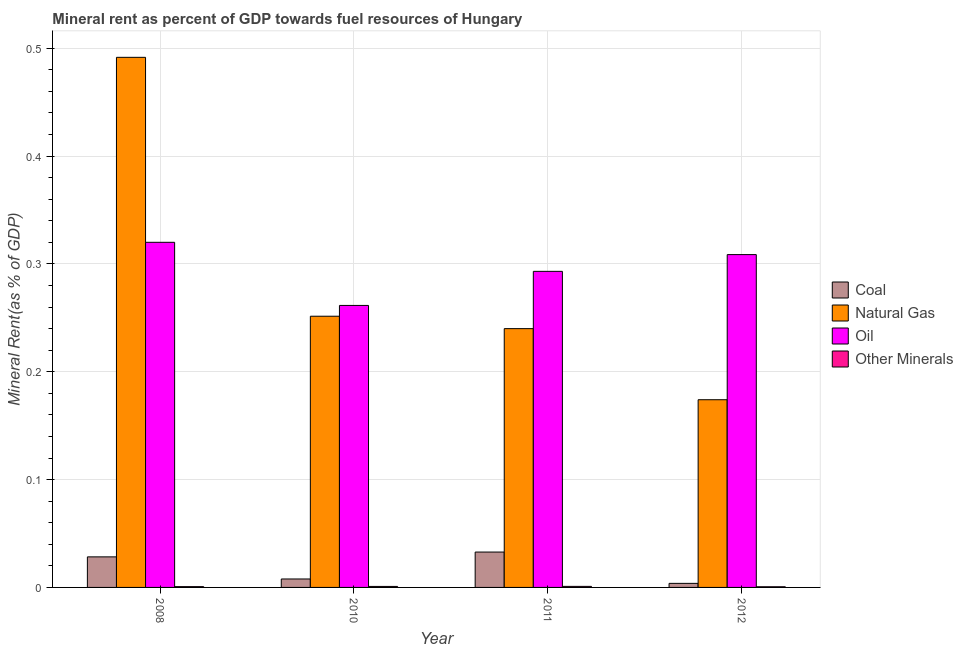How many different coloured bars are there?
Ensure brevity in your answer.  4. How many bars are there on the 1st tick from the left?
Your response must be concise. 4. How many bars are there on the 3rd tick from the right?
Your answer should be very brief. 4. What is the label of the 4th group of bars from the left?
Give a very brief answer. 2012. What is the oil rent in 2008?
Offer a very short reply. 0.32. Across all years, what is the maximum oil rent?
Make the answer very short. 0.32. Across all years, what is the minimum oil rent?
Offer a very short reply. 0.26. In which year was the  rent of other minerals maximum?
Keep it short and to the point. 2011. In which year was the  rent of other minerals minimum?
Your response must be concise. 2012. What is the total coal rent in the graph?
Offer a terse response. 0.07. What is the difference between the  rent of other minerals in 2010 and that in 2011?
Keep it short and to the point. -4.0162423750447e-5. What is the difference between the coal rent in 2008 and the oil rent in 2012?
Offer a terse response. 0.02. What is the average coal rent per year?
Provide a short and direct response. 0.02. What is the ratio of the oil rent in 2011 to that in 2012?
Ensure brevity in your answer.  0.95. Is the oil rent in 2010 less than that in 2011?
Provide a short and direct response. Yes. What is the difference between the highest and the second highest natural gas rent?
Offer a very short reply. 0.24. What is the difference between the highest and the lowest natural gas rent?
Offer a terse response. 0.32. Is it the case that in every year, the sum of the coal rent and  rent of other minerals is greater than the sum of oil rent and natural gas rent?
Provide a succinct answer. No. What does the 3rd bar from the left in 2010 represents?
Offer a very short reply. Oil. What does the 3rd bar from the right in 2012 represents?
Provide a short and direct response. Natural Gas. Is it the case that in every year, the sum of the coal rent and natural gas rent is greater than the oil rent?
Ensure brevity in your answer.  No. How many bars are there?
Your answer should be very brief. 16. Are all the bars in the graph horizontal?
Provide a succinct answer. No. How many years are there in the graph?
Give a very brief answer. 4. Does the graph contain any zero values?
Give a very brief answer. No. Does the graph contain grids?
Give a very brief answer. Yes. Where does the legend appear in the graph?
Provide a short and direct response. Center right. How many legend labels are there?
Offer a terse response. 4. How are the legend labels stacked?
Give a very brief answer. Vertical. What is the title of the graph?
Your response must be concise. Mineral rent as percent of GDP towards fuel resources of Hungary. What is the label or title of the Y-axis?
Your answer should be compact. Mineral Rent(as % of GDP). What is the Mineral Rent(as % of GDP) of Coal in 2008?
Give a very brief answer. 0.03. What is the Mineral Rent(as % of GDP) in Natural Gas in 2008?
Provide a succinct answer. 0.49. What is the Mineral Rent(as % of GDP) in Oil in 2008?
Provide a short and direct response. 0.32. What is the Mineral Rent(as % of GDP) in Other Minerals in 2008?
Give a very brief answer. 0. What is the Mineral Rent(as % of GDP) in Coal in 2010?
Provide a succinct answer. 0.01. What is the Mineral Rent(as % of GDP) in Natural Gas in 2010?
Your answer should be very brief. 0.25. What is the Mineral Rent(as % of GDP) of Oil in 2010?
Give a very brief answer. 0.26. What is the Mineral Rent(as % of GDP) of Other Minerals in 2010?
Ensure brevity in your answer.  0. What is the Mineral Rent(as % of GDP) in Coal in 2011?
Ensure brevity in your answer.  0.03. What is the Mineral Rent(as % of GDP) of Natural Gas in 2011?
Offer a very short reply. 0.24. What is the Mineral Rent(as % of GDP) in Oil in 2011?
Offer a very short reply. 0.29. What is the Mineral Rent(as % of GDP) of Other Minerals in 2011?
Offer a very short reply. 0. What is the Mineral Rent(as % of GDP) of Coal in 2012?
Offer a very short reply. 0. What is the Mineral Rent(as % of GDP) in Natural Gas in 2012?
Provide a short and direct response. 0.17. What is the Mineral Rent(as % of GDP) in Oil in 2012?
Keep it short and to the point. 0.31. What is the Mineral Rent(as % of GDP) of Other Minerals in 2012?
Offer a terse response. 0. Across all years, what is the maximum Mineral Rent(as % of GDP) in Coal?
Offer a terse response. 0.03. Across all years, what is the maximum Mineral Rent(as % of GDP) in Natural Gas?
Your answer should be very brief. 0.49. Across all years, what is the maximum Mineral Rent(as % of GDP) of Oil?
Your answer should be compact. 0.32. Across all years, what is the maximum Mineral Rent(as % of GDP) of Other Minerals?
Offer a terse response. 0. Across all years, what is the minimum Mineral Rent(as % of GDP) of Coal?
Make the answer very short. 0. Across all years, what is the minimum Mineral Rent(as % of GDP) in Natural Gas?
Your response must be concise. 0.17. Across all years, what is the minimum Mineral Rent(as % of GDP) in Oil?
Keep it short and to the point. 0.26. Across all years, what is the minimum Mineral Rent(as % of GDP) of Other Minerals?
Offer a very short reply. 0. What is the total Mineral Rent(as % of GDP) of Coal in the graph?
Keep it short and to the point. 0.07. What is the total Mineral Rent(as % of GDP) in Natural Gas in the graph?
Your answer should be very brief. 1.16. What is the total Mineral Rent(as % of GDP) in Oil in the graph?
Ensure brevity in your answer.  1.18. What is the total Mineral Rent(as % of GDP) in Other Minerals in the graph?
Provide a short and direct response. 0. What is the difference between the Mineral Rent(as % of GDP) of Coal in 2008 and that in 2010?
Your response must be concise. 0.02. What is the difference between the Mineral Rent(as % of GDP) of Natural Gas in 2008 and that in 2010?
Your answer should be compact. 0.24. What is the difference between the Mineral Rent(as % of GDP) in Oil in 2008 and that in 2010?
Make the answer very short. 0.06. What is the difference between the Mineral Rent(as % of GDP) of Other Minerals in 2008 and that in 2010?
Provide a succinct answer. -0. What is the difference between the Mineral Rent(as % of GDP) in Coal in 2008 and that in 2011?
Your answer should be very brief. -0. What is the difference between the Mineral Rent(as % of GDP) in Natural Gas in 2008 and that in 2011?
Ensure brevity in your answer.  0.25. What is the difference between the Mineral Rent(as % of GDP) of Oil in 2008 and that in 2011?
Your answer should be very brief. 0.03. What is the difference between the Mineral Rent(as % of GDP) of Other Minerals in 2008 and that in 2011?
Make the answer very short. -0. What is the difference between the Mineral Rent(as % of GDP) of Coal in 2008 and that in 2012?
Offer a terse response. 0.02. What is the difference between the Mineral Rent(as % of GDP) in Natural Gas in 2008 and that in 2012?
Offer a terse response. 0.32. What is the difference between the Mineral Rent(as % of GDP) in Oil in 2008 and that in 2012?
Your answer should be compact. 0.01. What is the difference between the Mineral Rent(as % of GDP) in Coal in 2010 and that in 2011?
Ensure brevity in your answer.  -0.03. What is the difference between the Mineral Rent(as % of GDP) of Natural Gas in 2010 and that in 2011?
Offer a terse response. 0.01. What is the difference between the Mineral Rent(as % of GDP) of Oil in 2010 and that in 2011?
Your answer should be compact. -0.03. What is the difference between the Mineral Rent(as % of GDP) in Coal in 2010 and that in 2012?
Provide a succinct answer. 0. What is the difference between the Mineral Rent(as % of GDP) in Natural Gas in 2010 and that in 2012?
Provide a succinct answer. 0.08. What is the difference between the Mineral Rent(as % of GDP) in Oil in 2010 and that in 2012?
Offer a terse response. -0.05. What is the difference between the Mineral Rent(as % of GDP) of Other Minerals in 2010 and that in 2012?
Your answer should be very brief. 0. What is the difference between the Mineral Rent(as % of GDP) in Coal in 2011 and that in 2012?
Your response must be concise. 0.03. What is the difference between the Mineral Rent(as % of GDP) in Natural Gas in 2011 and that in 2012?
Keep it short and to the point. 0.07. What is the difference between the Mineral Rent(as % of GDP) of Oil in 2011 and that in 2012?
Your response must be concise. -0.02. What is the difference between the Mineral Rent(as % of GDP) of Coal in 2008 and the Mineral Rent(as % of GDP) of Natural Gas in 2010?
Give a very brief answer. -0.22. What is the difference between the Mineral Rent(as % of GDP) of Coal in 2008 and the Mineral Rent(as % of GDP) of Oil in 2010?
Give a very brief answer. -0.23. What is the difference between the Mineral Rent(as % of GDP) in Coal in 2008 and the Mineral Rent(as % of GDP) in Other Minerals in 2010?
Provide a succinct answer. 0.03. What is the difference between the Mineral Rent(as % of GDP) of Natural Gas in 2008 and the Mineral Rent(as % of GDP) of Oil in 2010?
Provide a short and direct response. 0.23. What is the difference between the Mineral Rent(as % of GDP) of Natural Gas in 2008 and the Mineral Rent(as % of GDP) of Other Minerals in 2010?
Your answer should be compact. 0.49. What is the difference between the Mineral Rent(as % of GDP) of Oil in 2008 and the Mineral Rent(as % of GDP) of Other Minerals in 2010?
Ensure brevity in your answer.  0.32. What is the difference between the Mineral Rent(as % of GDP) of Coal in 2008 and the Mineral Rent(as % of GDP) of Natural Gas in 2011?
Your answer should be very brief. -0.21. What is the difference between the Mineral Rent(as % of GDP) of Coal in 2008 and the Mineral Rent(as % of GDP) of Oil in 2011?
Your answer should be compact. -0.26. What is the difference between the Mineral Rent(as % of GDP) of Coal in 2008 and the Mineral Rent(as % of GDP) of Other Minerals in 2011?
Your response must be concise. 0.03. What is the difference between the Mineral Rent(as % of GDP) in Natural Gas in 2008 and the Mineral Rent(as % of GDP) in Oil in 2011?
Ensure brevity in your answer.  0.2. What is the difference between the Mineral Rent(as % of GDP) of Natural Gas in 2008 and the Mineral Rent(as % of GDP) of Other Minerals in 2011?
Keep it short and to the point. 0.49. What is the difference between the Mineral Rent(as % of GDP) of Oil in 2008 and the Mineral Rent(as % of GDP) of Other Minerals in 2011?
Your answer should be very brief. 0.32. What is the difference between the Mineral Rent(as % of GDP) of Coal in 2008 and the Mineral Rent(as % of GDP) of Natural Gas in 2012?
Offer a terse response. -0.15. What is the difference between the Mineral Rent(as % of GDP) of Coal in 2008 and the Mineral Rent(as % of GDP) of Oil in 2012?
Your response must be concise. -0.28. What is the difference between the Mineral Rent(as % of GDP) in Coal in 2008 and the Mineral Rent(as % of GDP) in Other Minerals in 2012?
Your answer should be compact. 0.03. What is the difference between the Mineral Rent(as % of GDP) in Natural Gas in 2008 and the Mineral Rent(as % of GDP) in Oil in 2012?
Your answer should be compact. 0.18. What is the difference between the Mineral Rent(as % of GDP) of Natural Gas in 2008 and the Mineral Rent(as % of GDP) of Other Minerals in 2012?
Offer a very short reply. 0.49. What is the difference between the Mineral Rent(as % of GDP) of Oil in 2008 and the Mineral Rent(as % of GDP) of Other Minerals in 2012?
Offer a very short reply. 0.32. What is the difference between the Mineral Rent(as % of GDP) of Coal in 2010 and the Mineral Rent(as % of GDP) of Natural Gas in 2011?
Your answer should be very brief. -0.23. What is the difference between the Mineral Rent(as % of GDP) in Coal in 2010 and the Mineral Rent(as % of GDP) in Oil in 2011?
Your answer should be very brief. -0.29. What is the difference between the Mineral Rent(as % of GDP) of Coal in 2010 and the Mineral Rent(as % of GDP) of Other Minerals in 2011?
Your response must be concise. 0.01. What is the difference between the Mineral Rent(as % of GDP) in Natural Gas in 2010 and the Mineral Rent(as % of GDP) in Oil in 2011?
Keep it short and to the point. -0.04. What is the difference between the Mineral Rent(as % of GDP) in Natural Gas in 2010 and the Mineral Rent(as % of GDP) in Other Minerals in 2011?
Give a very brief answer. 0.25. What is the difference between the Mineral Rent(as % of GDP) of Oil in 2010 and the Mineral Rent(as % of GDP) of Other Minerals in 2011?
Offer a terse response. 0.26. What is the difference between the Mineral Rent(as % of GDP) of Coal in 2010 and the Mineral Rent(as % of GDP) of Natural Gas in 2012?
Your answer should be very brief. -0.17. What is the difference between the Mineral Rent(as % of GDP) in Coal in 2010 and the Mineral Rent(as % of GDP) in Oil in 2012?
Ensure brevity in your answer.  -0.3. What is the difference between the Mineral Rent(as % of GDP) of Coal in 2010 and the Mineral Rent(as % of GDP) of Other Minerals in 2012?
Provide a short and direct response. 0.01. What is the difference between the Mineral Rent(as % of GDP) of Natural Gas in 2010 and the Mineral Rent(as % of GDP) of Oil in 2012?
Provide a short and direct response. -0.06. What is the difference between the Mineral Rent(as % of GDP) in Natural Gas in 2010 and the Mineral Rent(as % of GDP) in Other Minerals in 2012?
Your response must be concise. 0.25. What is the difference between the Mineral Rent(as % of GDP) in Oil in 2010 and the Mineral Rent(as % of GDP) in Other Minerals in 2012?
Give a very brief answer. 0.26. What is the difference between the Mineral Rent(as % of GDP) of Coal in 2011 and the Mineral Rent(as % of GDP) of Natural Gas in 2012?
Offer a terse response. -0.14. What is the difference between the Mineral Rent(as % of GDP) of Coal in 2011 and the Mineral Rent(as % of GDP) of Oil in 2012?
Provide a short and direct response. -0.28. What is the difference between the Mineral Rent(as % of GDP) of Coal in 2011 and the Mineral Rent(as % of GDP) of Other Minerals in 2012?
Your answer should be very brief. 0.03. What is the difference between the Mineral Rent(as % of GDP) in Natural Gas in 2011 and the Mineral Rent(as % of GDP) in Oil in 2012?
Make the answer very short. -0.07. What is the difference between the Mineral Rent(as % of GDP) of Natural Gas in 2011 and the Mineral Rent(as % of GDP) of Other Minerals in 2012?
Make the answer very short. 0.24. What is the difference between the Mineral Rent(as % of GDP) in Oil in 2011 and the Mineral Rent(as % of GDP) in Other Minerals in 2012?
Keep it short and to the point. 0.29. What is the average Mineral Rent(as % of GDP) in Coal per year?
Give a very brief answer. 0.02. What is the average Mineral Rent(as % of GDP) of Natural Gas per year?
Ensure brevity in your answer.  0.29. What is the average Mineral Rent(as % of GDP) in Oil per year?
Ensure brevity in your answer.  0.3. What is the average Mineral Rent(as % of GDP) of Other Minerals per year?
Make the answer very short. 0. In the year 2008, what is the difference between the Mineral Rent(as % of GDP) of Coal and Mineral Rent(as % of GDP) of Natural Gas?
Offer a very short reply. -0.46. In the year 2008, what is the difference between the Mineral Rent(as % of GDP) of Coal and Mineral Rent(as % of GDP) of Oil?
Make the answer very short. -0.29. In the year 2008, what is the difference between the Mineral Rent(as % of GDP) of Coal and Mineral Rent(as % of GDP) of Other Minerals?
Provide a short and direct response. 0.03. In the year 2008, what is the difference between the Mineral Rent(as % of GDP) in Natural Gas and Mineral Rent(as % of GDP) in Oil?
Make the answer very short. 0.17. In the year 2008, what is the difference between the Mineral Rent(as % of GDP) in Natural Gas and Mineral Rent(as % of GDP) in Other Minerals?
Make the answer very short. 0.49. In the year 2008, what is the difference between the Mineral Rent(as % of GDP) of Oil and Mineral Rent(as % of GDP) of Other Minerals?
Your response must be concise. 0.32. In the year 2010, what is the difference between the Mineral Rent(as % of GDP) in Coal and Mineral Rent(as % of GDP) in Natural Gas?
Your response must be concise. -0.24. In the year 2010, what is the difference between the Mineral Rent(as % of GDP) of Coal and Mineral Rent(as % of GDP) of Oil?
Make the answer very short. -0.25. In the year 2010, what is the difference between the Mineral Rent(as % of GDP) in Coal and Mineral Rent(as % of GDP) in Other Minerals?
Make the answer very short. 0.01. In the year 2010, what is the difference between the Mineral Rent(as % of GDP) in Natural Gas and Mineral Rent(as % of GDP) in Oil?
Provide a succinct answer. -0.01. In the year 2010, what is the difference between the Mineral Rent(as % of GDP) of Natural Gas and Mineral Rent(as % of GDP) of Other Minerals?
Keep it short and to the point. 0.25. In the year 2010, what is the difference between the Mineral Rent(as % of GDP) of Oil and Mineral Rent(as % of GDP) of Other Minerals?
Provide a succinct answer. 0.26. In the year 2011, what is the difference between the Mineral Rent(as % of GDP) in Coal and Mineral Rent(as % of GDP) in Natural Gas?
Make the answer very short. -0.21. In the year 2011, what is the difference between the Mineral Rent(as % of GDP) in Coal and Mineral Rent(as % of GDP) in Oil?
Your answer should be very brief. -0.26. In the year 2011, what is the difference between the Mineral Rent(as % of GDP) in Coal and Mineral Rent(as % of GDP) in Other Minerals?
Give a very brief answer. 0.03. In the year 2011, what is the difference between the Mineral Rent(as % of GDP) of Natural Gas and Mineral Rent(as % of GDP) of Oil?
Provide a succinct answer. -0.05. In the year 2011, what is the difference between the Mineral Rent(as % of GDP) in Natural Gas and Mineral Rent(as % of GDP) in Other Minerals?
Make the answer very short. 0.24. In the year 2011, what is the difference between the Mineral Rent(as % of GDP) of Oil and Mineral Rent(as % of GDP) of Other Minerals?
Your answer should be compact. 0.29. In the year 2012, what is the difference between the Mineral Rent(as % of GDP) of Coal and Mineral Rent(as % of GDP) of Natural Gas?
Ensure brevity in your answer.  -0.17. In the year 2012, what is the difference between the Mineral Rent(as % of GDP) of Coal and Mineral Rent(as % of GDP) of Oil?
Your response must be concise. -0.3. In the year 2012, what is the difference between the Mineral Rent(as % of GDP) of Coal and Mineral Rent(as % of GDP) of Other Minerals?
Make the answer very short. 0. In the year 2012, what is the difference between the Mineral Rent(as % of GDP) in Natural Gas and Mineral Rent(as % of GDP) in Oil?
Provide a succinct answer. -0.13. In the year 2012, what is the difference between the Mineral Rent(as % of GDP) in Natural Gas and Mineral Rent(as % of GDP) in Other Minerals?
Give a very brief answer. 0.17. In the year 2012, what is the difference between the Mineral Rent(as % of GDP) in Oil and Mineral Rent(as % of GDP) in Other Minerals?
Your response must be concise. 0.31. What is the ratio of the Mineral Rent(as % of GDP) in Coal in 2008 to that in 2010?
Offer a very short reply. 3.61. What is the ratio of the Mineral Rent(as % of GDP) in Natural Gas in 2008 to that in 2010?
Your answer should be very brief. 1.95. What is the ratio of the Mineral Rent(as % of GDP) of Oil in 2008 to that in 2010?
Keep it short and to the point. 1.22. What is the ratio of the Mineral Rent(as % of GDP) of Other Minerals in 2008 to that in 2010?
Your response must be concise. 0.79. What is the ratio of the Mineral Rent(as % of GDP) in Coal in 2008 to that in 2011?
Your answer should be very brief. 0.86. What is the ratio of the Mineral Rent(as % of GDP) of Natural Gas in 2008 to that in 2011?
Ensure brevity in your answer.  2.05. What is the ratio of the Mineral Rent(as % of GDP) in Oil in 2008 to that in 2011?
Your answer should be compact. 1.09. What is the ratio of the Mineral Rent(as % of GDP) in Other Minerals in 2008 to that in 2011?
Provide a short and direct response. 0.76. What is the ratio of the Mineral Rent(as % of GDP) in Coal in 2008 to that in 2012?
Give a very brief answer. 7.53. What is the ratio of the Mineral Rent(as % of GDP) in Natural Gas in 2008 to that in 2012?
Keep it short and to the point. 2.82. What is the ratio of the Mineral Rent(as % of GDP) in Oil in 2008 to that in 2012?
Provide a short and direct response. 1.04. What is the ratio of the Mineral Rent(as % of GDP) of Other Minerals in 2008 to that in 2012?
Keep it short and to the point. 1.18. What is the ratio of the Mineral Rent(as % of GDP) of Coal in 2010 to that in 2011?
Your response must be concise. 0.24. What is the ratio of the Mineral Rent(as % of GDP) in Natural Gas in 2010 to that in 2011?
Provide a short and direct response. 1.05. What is the ratio of the Mineral Rent(as % of GDP) in Oil in 2010 to that in 2011?
Your answer should be compact. 0.89. What is the ratio of the Mineral Rent(as % of GDP) in Other Minerals in 2010 to that in 2011?
Your answer should be very brief. 0.96. What is the ratio of the Mineral Rent(as % of GDP) in Coal in 2010 to that in 2012?
Offer a very short reply. 2.08. What is the ratio of the Mineral Rent(as % of GDP) of Natural Gas in 2010 to that in 2012?
Your answer should be compact. 1.44. What is the ratio of the Mineral Rent(as % of GDP) of Oil in 2010 to that in 2012?
Your answer should be compact. 0.85. What is the ratio of the Mineral Rent(as % of GDP) in Other Minerals in 2010 to that in 2012?
Offer a very short reply. 1.49. What is the ratio of the Mineral Rent(as % of GDP) in Coal in 2011 to that in 2012?
Make the answer very short. 8.72. What is the ratio of the Mineral Rent(as % of GDP) in Natural Gas in 2011 to that in 2012?
Give a very brief answer. 1.38. What is the ratio of the Mineral Rent(as % of GDP) in Oil in 2011 to that in 2012?
Give a very brief answer. 0.95. What is the ratio of the Mineral Rent(as % of GDP) in Other Minerals in 2011 to that in 2012?
Provide a short and direct response. 1.56. What is the difference between the highest and the second highest Mineral Rent(as % of GDP) of Coal?
Offer a terse response. 0. What is the difference between the highest and the second highest Mineral Rent(as % of GDP) in Natural Gas?
Ensure brevity in your answer.  0.24. What is the difference between the highest and the second highest Mineral Rent(as % of GDP) of Oil?
Offer a very short reply. 0.01. What is the difference between the highest and the lowest Mineral Rent(as % of GDP) in Coal?
Provide a short and direct response. 0.03. What is the difference between the highest and the lowest Mineral Rent(as % of GDP) of Natural Gas?
Provide a short and direct response. 0.32. What is the difference between the highest and the lowest Mineral Rent(as % of GDP) of Oil?
Keep it short and to the point. 0.06. What is the difference between the highest and the lowest Mineral Rent(as % of GDP) in Other Minerals?
Your answer should be compact. 0. 